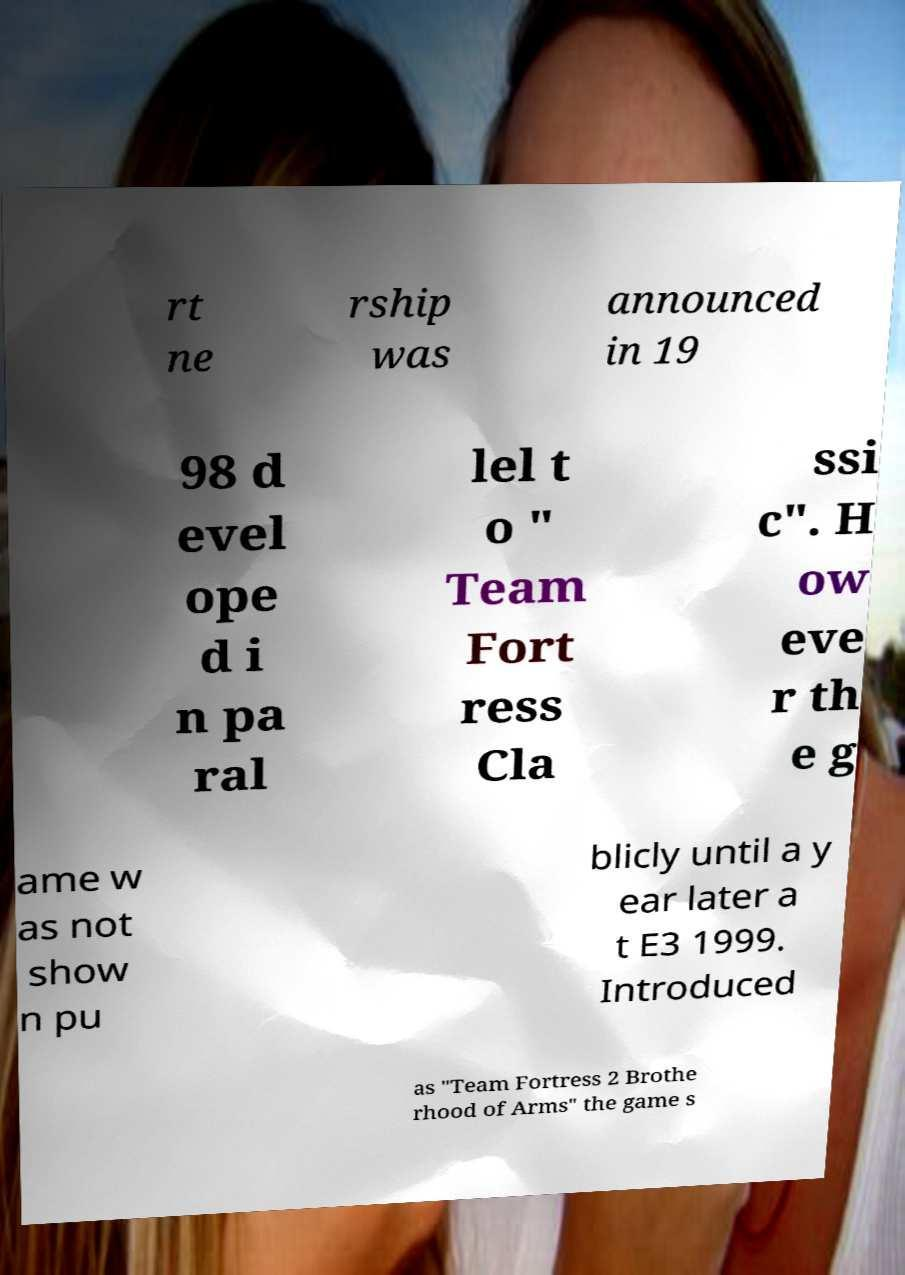What messages or text are displayed in this image? I need them in a readable, typed format. rt ne rship was announced in 19 98 d evel ope d i n pa ral lel t o " Team Fort ress Cla ssi c". H ow eve r th e g ame w as not show n pu blicly until a y ear later a t E3 1999. Introduced as "Team Fortress 2 Brothe rhood of Arms" the game s 